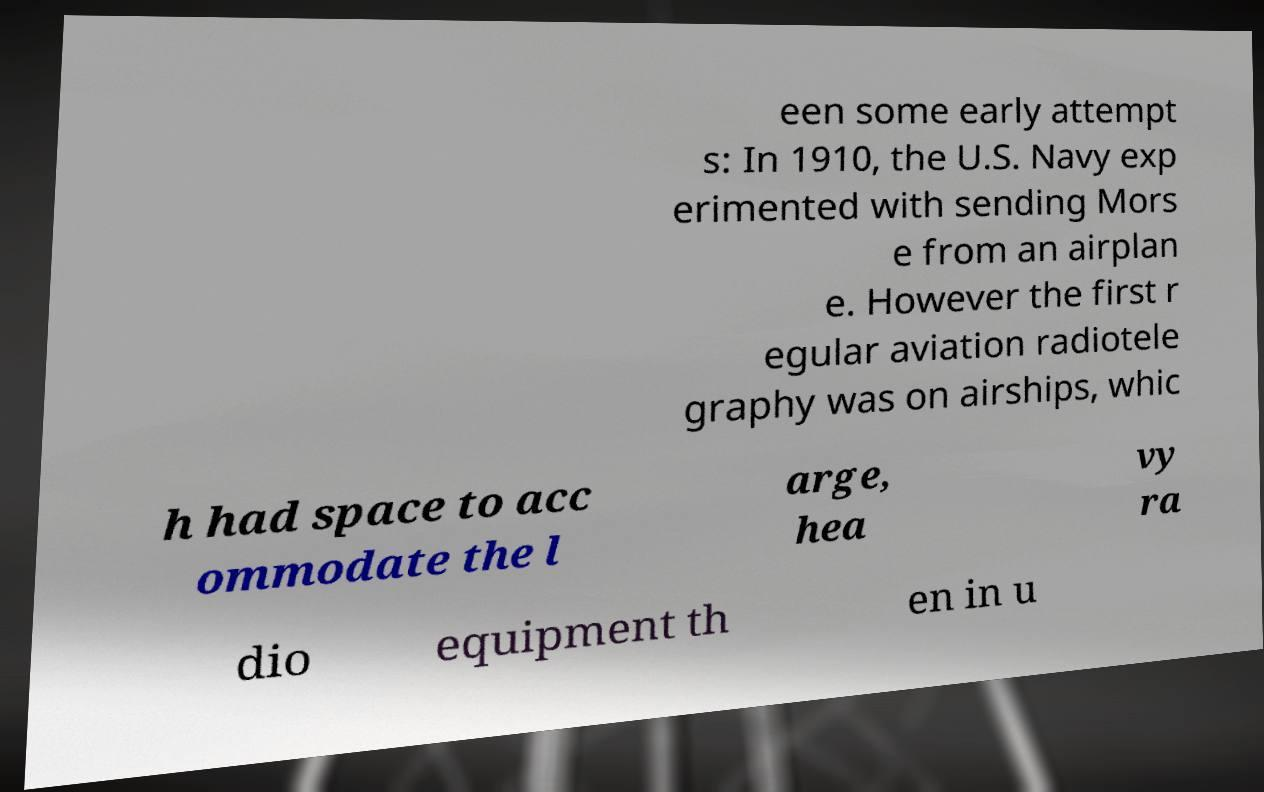Please identify and transcribe the text found in this image. een some early attempt s: In 1910, the U.S. Navy exp erimented with sending Mors e from an airplan e. However the first r egular aviation radiotele graphy was on airships, whic h had space to acc ommodate the l arge, hea vy ra dio equipment th en in u 